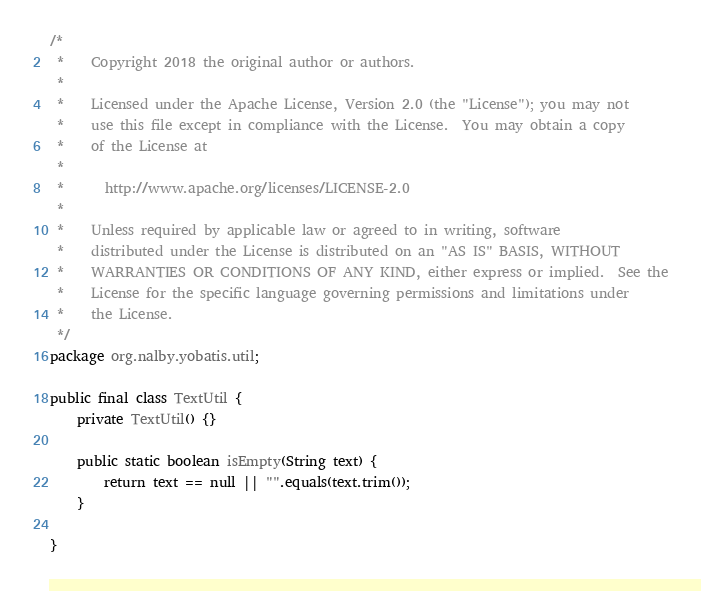Convert code to text. <code><loc_0><loc_0><loc_500><loc_500><_Java_>/*
 *    Copyright 2018 the original author or authors.
 *    
 *    Licensed under the Apache License, Version 2.0 (the "License"); you may not
 *    use this file except in compliance with the License.  You may obtain a copy
 *    of the License at
 *    
 *      http://www.apache.org/licenses/LICENSE-2.0
 *    
 *    Unless required by applicable law or agreed to in writing, software
 *    distributed under the License is distributed on an "AS IS" BASIS, WITHOUT
 *    WARRANTIES OR CONDITIONS OF ANY KIND, either express or implied.  See the
 *    License for the specific language governing permissions and limitations under
 *    the License.
 */
package org.nalby.yobatis.util;

public final class TextUtil {
	private TextUtil() {}
	
	public static boolean isEmpty(String text) {
		return text == null || "".equals(text.trim());
	}

}
</code> 